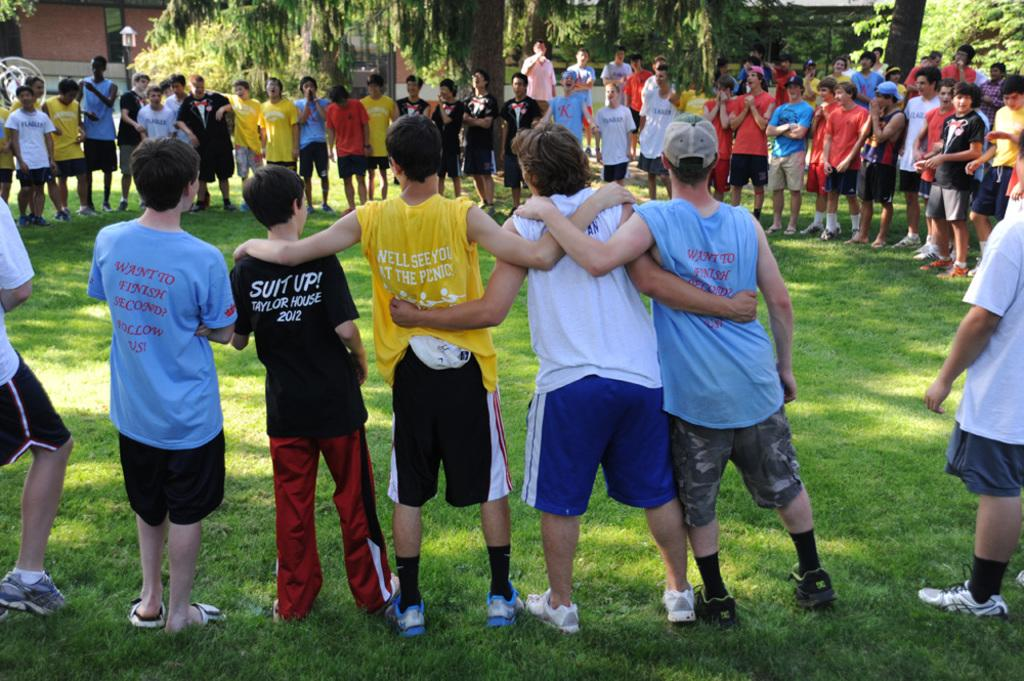<image>
Summarize the visual content of the image. A group of kids have formed a big circle and one boy has a black shirt with Suit Up on it. 